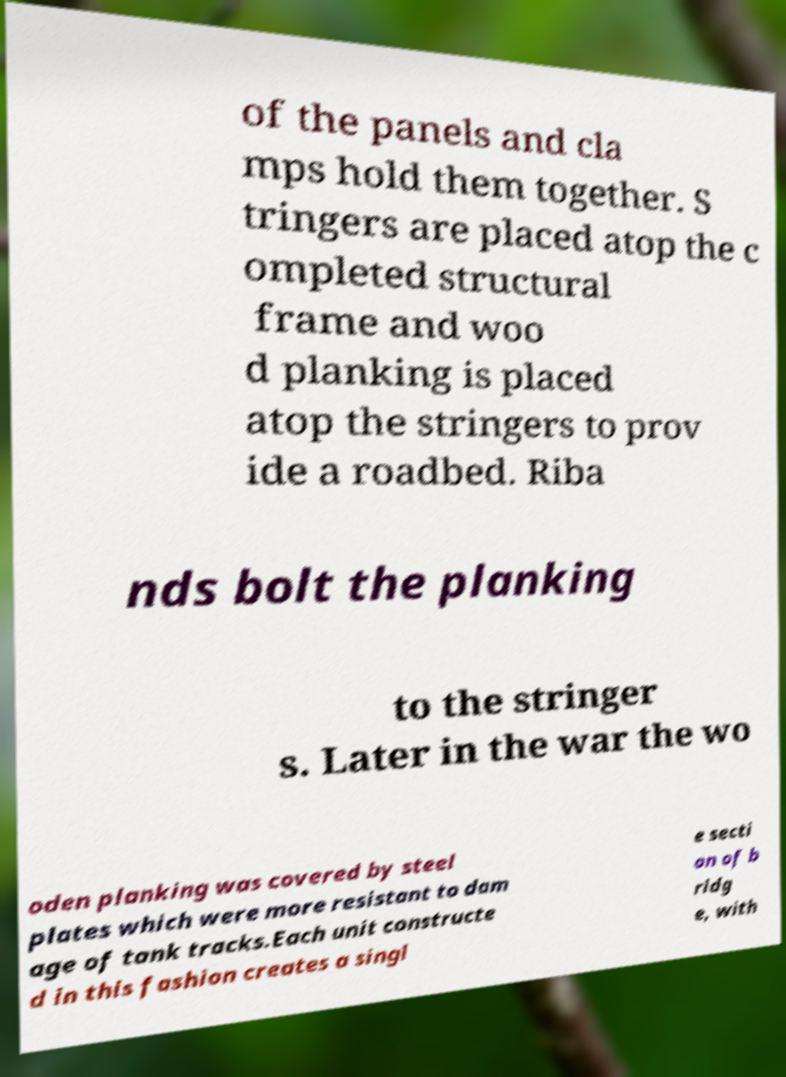Please read and relay the text visible in this image. What does it say? of the panels and cla mps hold them together. S tringers are placed atop the c ompleted structural frame and woo d planking is placed atop the stringers to prov ide a roadbed. Riba nds bolt the planking to the stringer s. Later in the war the wo oden planking was covered by steel plates which were more resistant to dam age of tank tracks.Each unit constructe d in this fashion creates a singl e secti on of b ridg e, with 